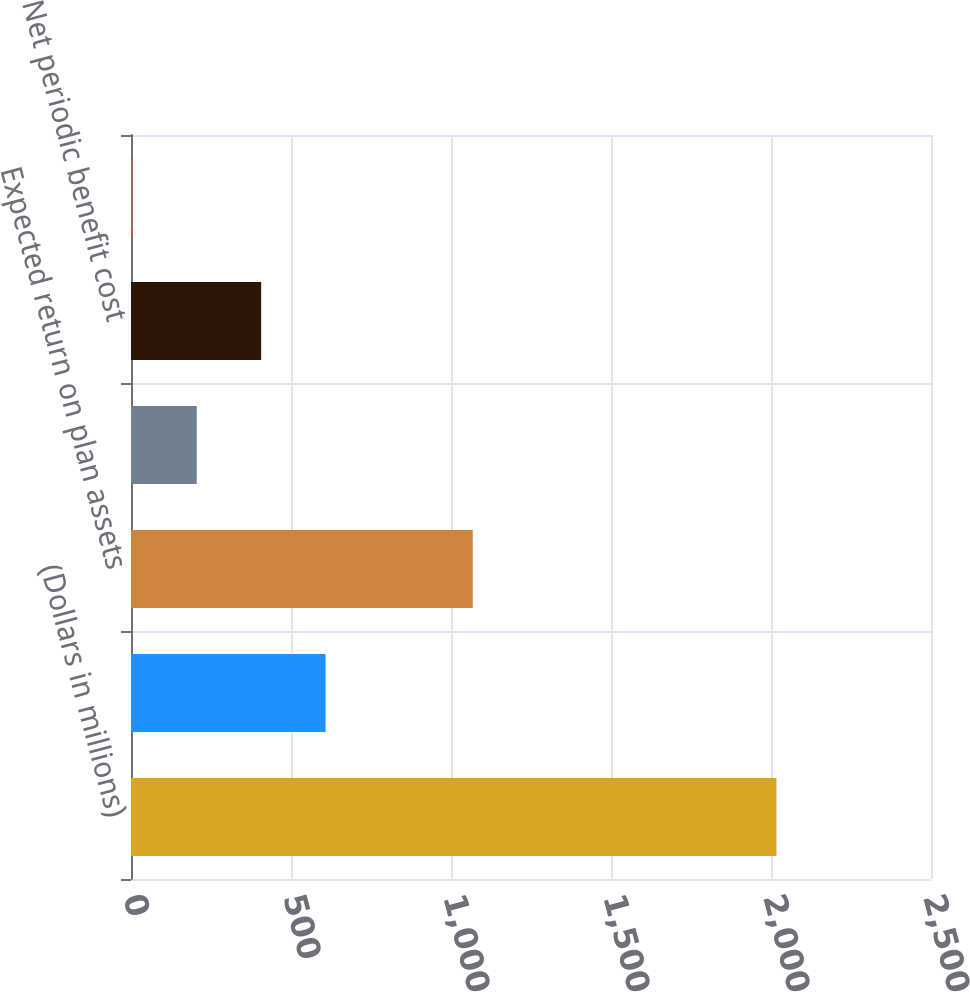Convert chart to OTSL. <chart><loc_0><loc_0><loc_500><loc_500><bar_chart><fcel>(Dollars in millions)<fcel>Interest cost<fcel>Expected return on plan assets<fcel>Amortization of net actuarial<fcel>Net periodic benefit cost<fcel>Discount rate<nl><fcel>2017<fcel>608<fcel>1068<fcel>205.44<fcel>406.72<fcel>4.16<nl></chart> 